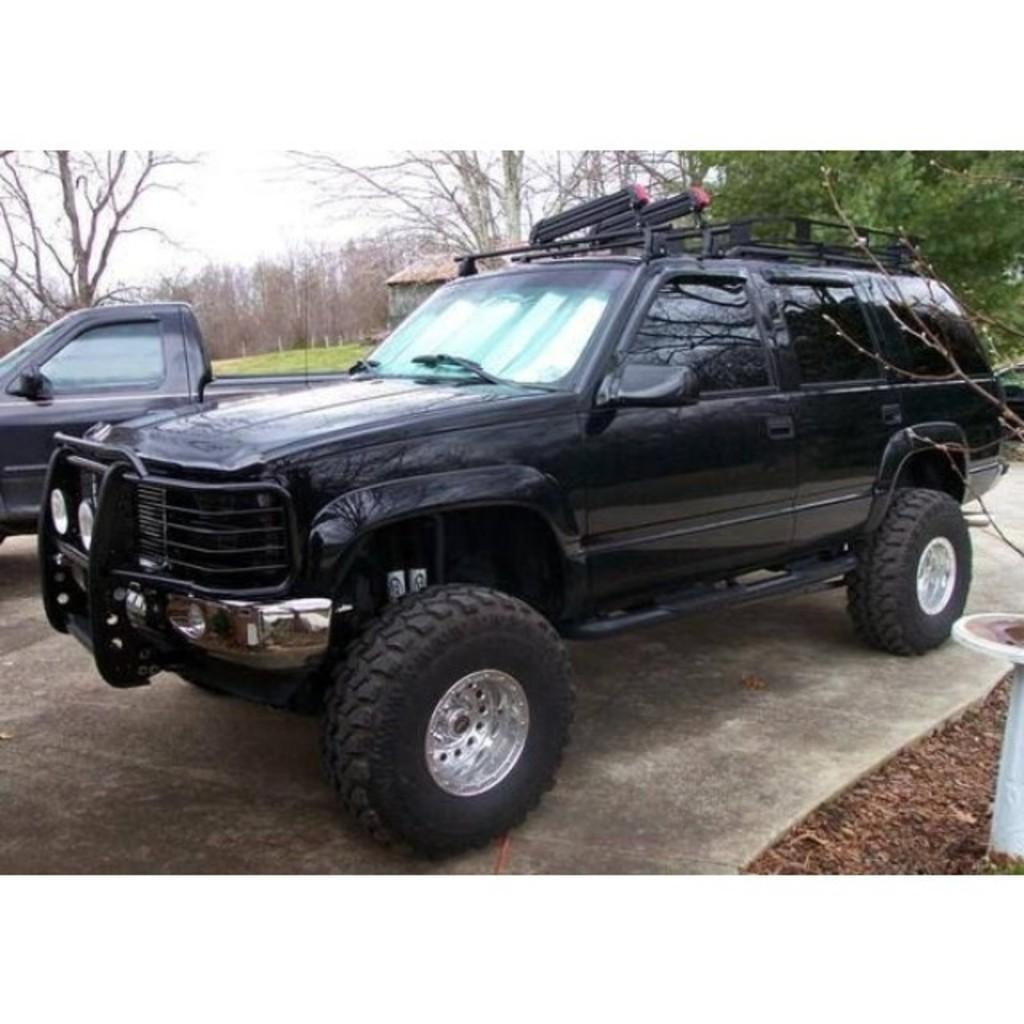Describe this image in one or two sentences. In this image we can see vehicles. In the background there are trees and sky. Also there is a shed. 